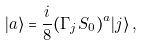<formula> <loc_0><loc_0><loc_500><loc_500>| a \rangle = \frac { i } { 8 } ( \Gamma _ { j } S _ { 0 } ) ^ { a } | j \rangle \, ,</formula> 